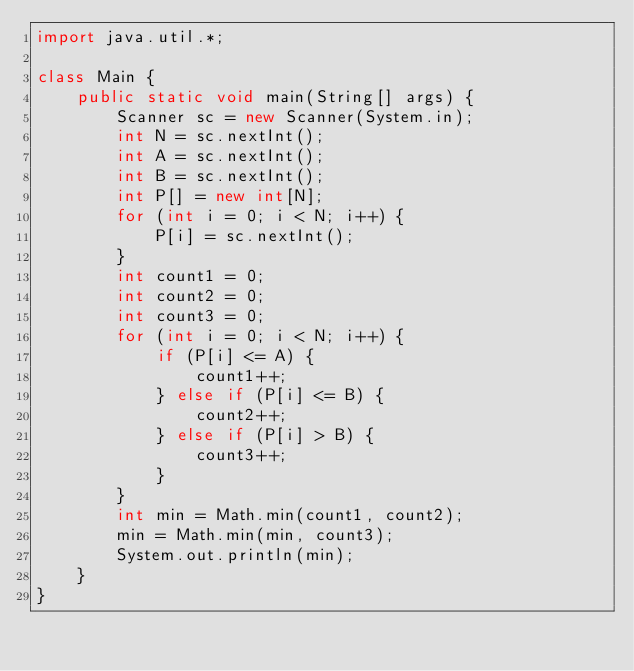<code> <loc_0><loc_0><loc_500><loc_500><_Java_>import java.util.*;

class Main {
    public static void main(String[] args) {
        Scanner sc = new Scanner(System.in);
        int N = sc.nextInt();
        int A = sc.nextInt();
        int B = sc.nextInt();
        int P[] = new int[N];
        for (int i = 0; i < N; i++) {
            P[i] = sc.nextInt();
        }
        int count1 = 0;
        int count2 = 0;
        int count3 = 0;
        for (int i = 0; i < N; i++) {
            if (P[i] <= A) {
                count1++;
            } else if (P[i] <= B) {
                count2++;
            } else if (P[i] > B) {
                count3++;
            }
        }
        int min = Math.min(count1, count2);
        min = Math.min(min, count3);
        System.out.println(min);
    }
}</code> 